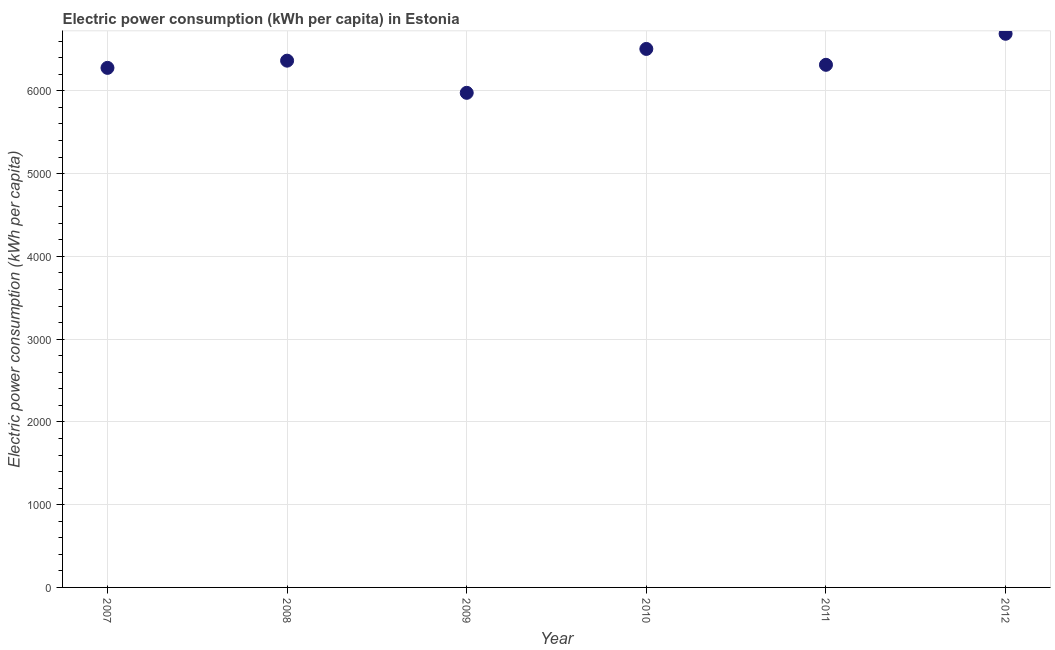What is the electric power consumption in 2011?
Offer a very short reply. 6314.41. Across all years, what is the maximum electric power consumption?
Your response must be concise. 6689.37. Across all years, what is the minimum electric power consumption?
Give a very brief answer. 5975.95. In which year was the electric power consumption maximum?
Ensure brevity in your answer.  2012. What is the sum of the electric power consumption?
Ensure brevity in your answer.  3.81e+04. What is the difference between the electric power consumption in 2008 and 2010?
Your answer should be compact. -141.75. What is the average electric power consumption per year?
Give a very brief answer. 6354.67. What is the median electric power consumption?
Keep it short and to the point. 6339.49. Do a majority of the years between 2012 and 2007 (inclusive) have electric power consumption greater than 4600 kWh per capita?
Your answer should be very brief. Yes. What is the ratio of the electric power consumption in 2007 to that in 2012?
Make the answer very short. 0.94. What is the difference between the highest and the second highest electric power consumption?
Your answer should be compact. 183.05. What is the difference between the highest and the lowest electric power consumption?
Offer a very short reply. 713.41. In how many years, is the electric power consumption greater than the average electric power consumption taken over all years?
Your response must be concise. 3. Does the electric power consumption monotonically increase over the years?
Your answer should be very brief. No. How many dotlines are there?
Your response must be concise. 1. Does the graph contain any zero values?
Your response must be concise. No. Does the graph contain grids?
Keep it short and to the point. Yes. What is the title of the graph?
Provide a succinct answer. Electric power consumption (kWh per capita) in Estonia. What is the label or title of the X-axis?
Your answer should be compact. Year. What is the label or title of the Y-axis?
Give a very brief answer. Electric power consumption (kWh per capita). What is the Electric power consumption (kWh per capita) in 2007?
Offer a very short reply. 6277.41. What is the Electric power consumption (kWh per capita) in 2008?
Your answer should be very brief. 6364.57. What is the Electric power consumption (kWh per capita) in 2009?
Make the answer very short. 5975.95. What is the Electric power consumption (kWh per capita) in 2010?
Give a very brief answer. 6506.32. What is the Electric power consumption (kWh per capita) in 2011?
Offer a very short reply. 6314.41. What is the Electric power consumption (kWh per capita) in 2012?
Give a very brief answer. 6689.37. What is the difference between the Electric power consumption (kWh per capita) in 2007 and 2008?
Keep it short and to the point. -87.16. What is the difference between the Electric power consumption (kWh per capita) in 2007 and 2009?
Give a very brief answer. 301.46. What is the difference between the Electric power consumption (kWh per capita) in 2007 and 2010?
Make the answer very short. -228.91. What is the difference between the Electric power consumption (kWh per capita) in 2007 and 2011?
Offer a very short reply. -37. What is the difference between the Electric power consumption (kWh per capita) in 2007 and 2012?
Make the answer very short. -411.96. What is the difference between the Electric power consumption (kWh per capita) in 2008 and 2009?
Your answer should be very brief. 388.61. What is the difference between the Electric power consumption (kWh per capita) in 2008 and 2010?
Keep it short and to the point. -141.75. What is the difference between the Electric power consumption (kWh per capita) in 2008 and 2011?
Your answer should be very brief. 50.15. What is the difference between the Electric power consumption (kWh per capita) in 2008 and 2012?
Give a very brief answer. -324.8. What is the difference between the Electric power consumption (kWh per capita) in 2009 and 2010?
Make the answer very short. -530.36. What is the difference between the Electric power consumption (kWh per capita) in 2009 and 2011?
Provide a short and direct response. -338.46. What is the difference between the Electric power consumption (kWh per capita) in 2009 and 2012?
Ensure brevity in your answer.  -713.41. What is the difference between the Electric power consumption (kWh per capita) in 2010 and 2011?
Your answer should be very brief. 191.9. What is the difference between the Electric power consumption (kWh per capita) in 2010 and 2012?
Provide a succinct answer. -183.05. What is the difference between the Electric power consumption (kWh per capita) in 2011 and 2012?
Provide a short and direct response. -374.95. What is the ratio of the Electric power consumption (kWh per capita) in 2007 to that in 2008?
Your answer should be very brief. 0.99. What is the ratio of the Electric power consumption (kWh per capita) in 2007 to that in 2010?
Keep it short and to the point. 0.96. What is the ratio of the Electric power consumption (kWh per capita) in 2007 to that in 2012?
Your response must be concise. 0.94. What is the ratio of the Electric power consumption (kWh per capita) in 2008 to that in 2009?
Your response must be concise. 1.06. What is the ratio of the Electric power consumption (kWh per capita) in 2008 to that in 2010?
Ensure brevity in your answer.  0.98. What is the ratio of the Electric power consumption (kWh per capita) in 2008 to that in 2012?
Offer a very short reply. 0.95. What is the ratio of the Electric power consumption (kWh per capita) in 2009 to that in 2010?
Offer a terse response. 0.92. What is the ratio of the Electric power consumption (kWh per capita) in 2009 to that in 2011?
Your response must be concise. 0.95. What is the ratio of the Electric power consumption (kWh per capita) in 2009 to that in 2012?
Your answer should be compact. 0.89. What is the ratio of the Electric power consumption (kWh per capita) in 2011 to that in 2012?
Your answer should be very brief. 0.94. 